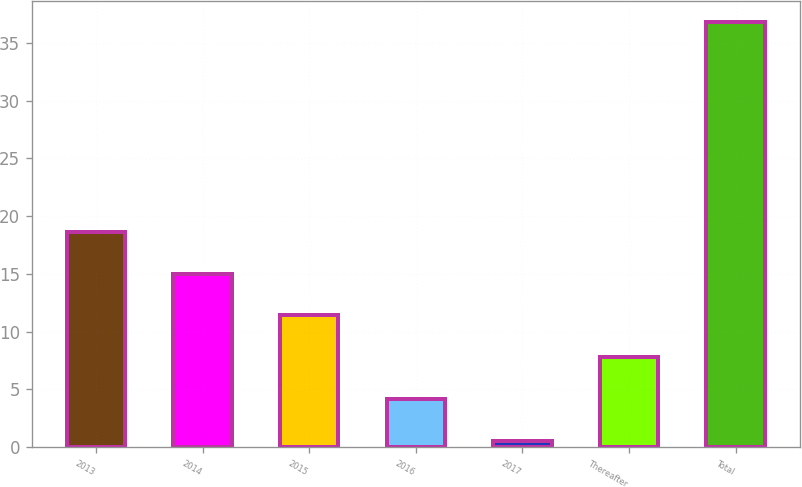Convert chart to OTSL. <chart><loc_0><loc_0><loc_500><loc_500><bar_chart><fcel>2013<fcel>2014<fcel>2015<fcel>2016<fcel>2017<fcel>Thereafter<fcel>Total<nl><fcel>18.65<fcel>15.02<fcel>11.39<fcel>4.13<fcel>0.5<fcel>7.76<fcel>36.8<nl></chart> 